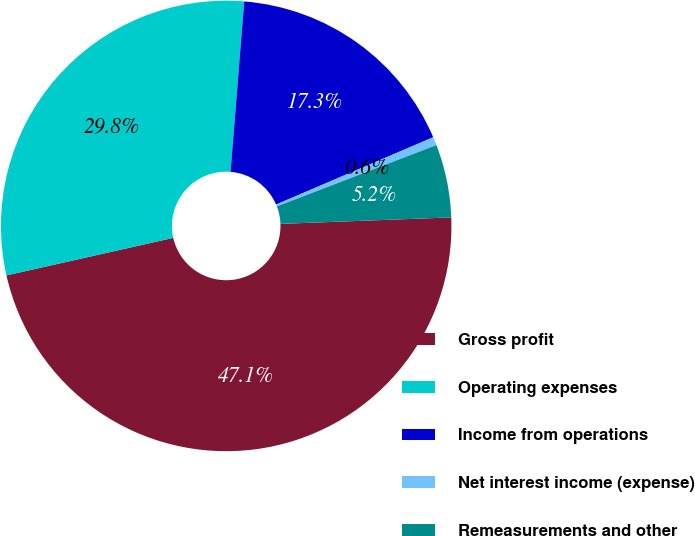<chart> <loc_0><loc_0><loc_500><loc_500><pie_chart><fcel>Gross profit<fcel>Operating expenses<fcel>Income from operations<fcel>Net interest income (expense)<fcel>Remeasurements and other<nl><fcel>47.08%<fcel>29.8%<fcel>17.28%<fcel>0.6%<fcel>5.24%<nl></chart> 